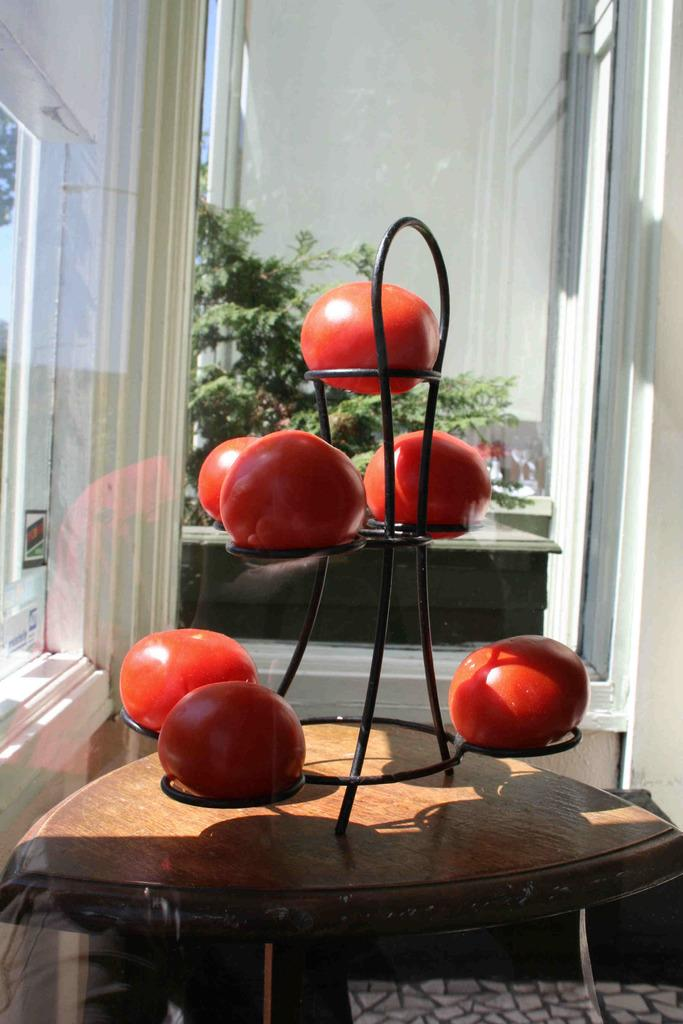What type of structure is visible in the picture? There is a house in the picture. What can be found inside the house? Inside the house, there is a table. What is on the table? On the table, there is a stand of tomatoes. What can be seen in the background of the picture? In the background of the picture, there are plants. What type of attraction is visible in the picture? There is no attraction visible in the picture; it features a house with a table and a stand of tomatoes, along with plants in the background. What is the wrist doing in the picture? There is no wrist visible in the picture; the image focuses on a house, a table, a stand of tomatoes, and plants in the background. 